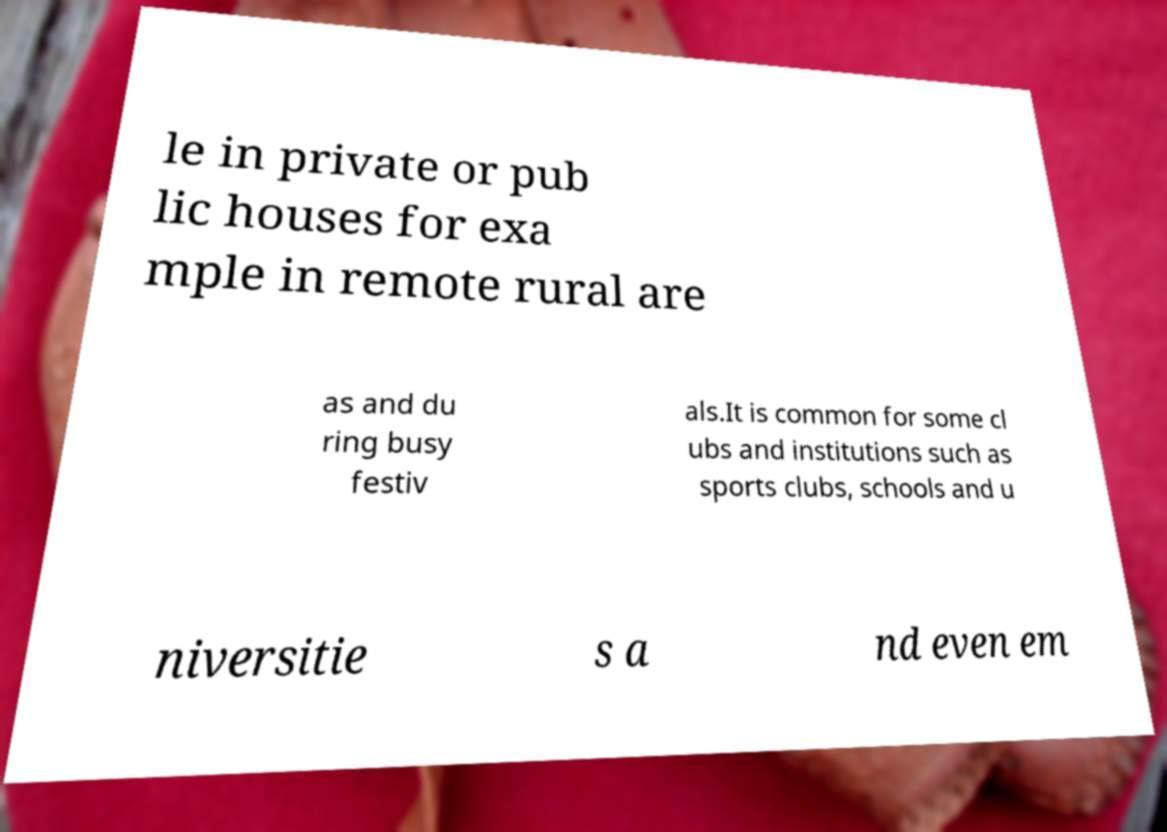Can you read and provide the text displayed in the image?This photo seems to have some interesting text. Can you extract and type it out for me? le in private or pub lic houses for exa mple in remote rural are as and du ring busy festiv als.It is common for some cl ubs and institutions such as sports clubs, schools and u niversitie s a nd even em 